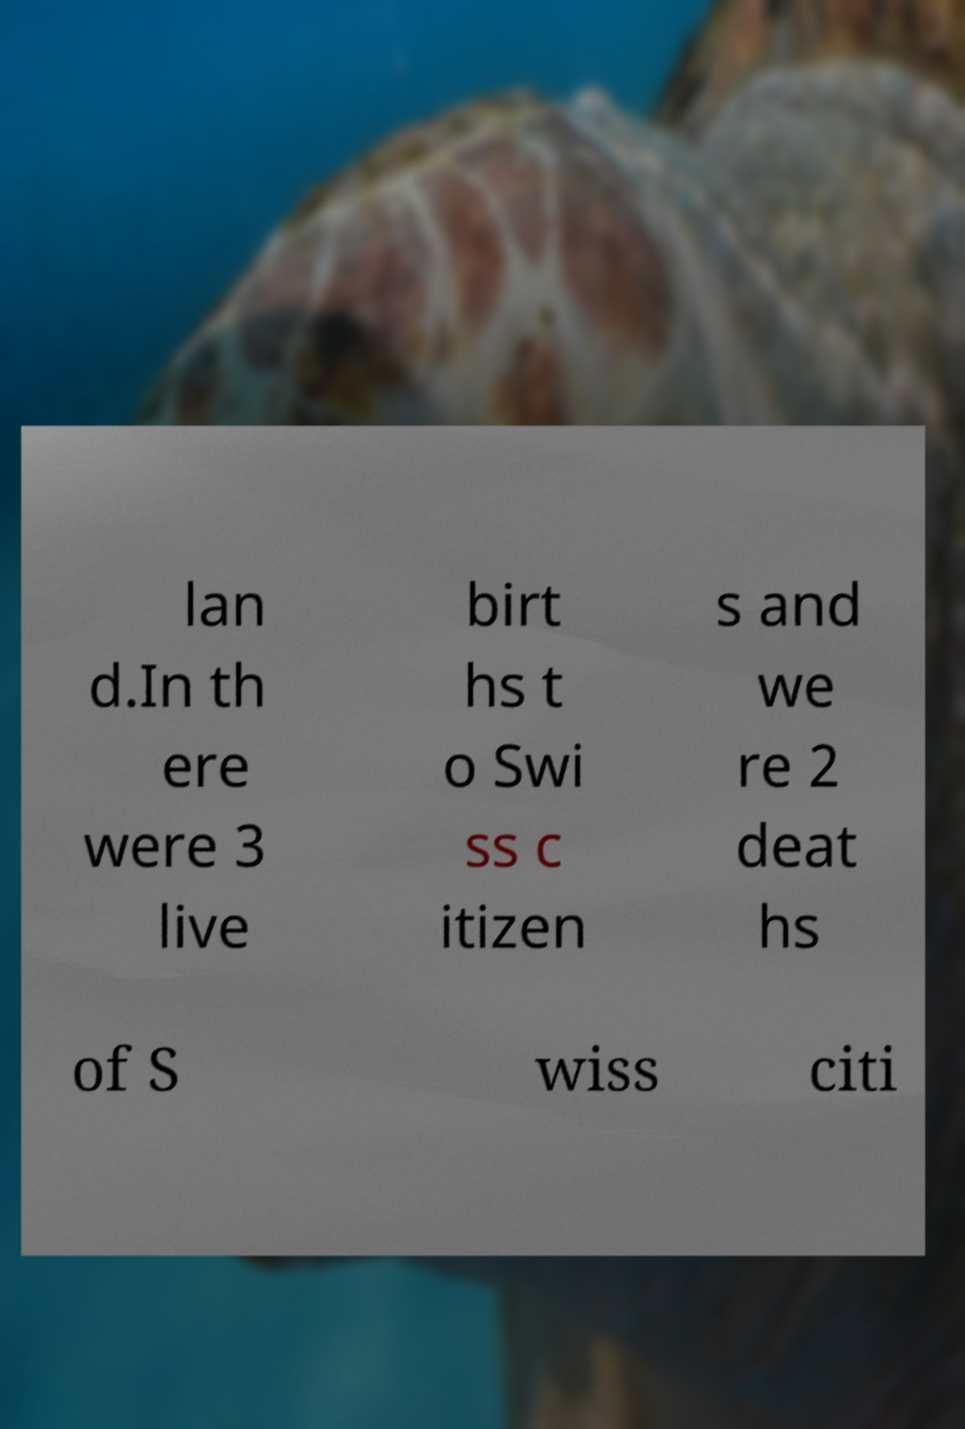Please identify and transcribe the text found in this image. lan d.In th ere were 3 live birt hs t o Swi ss c itizen s and we re 2 deat hs of S wiss citi 